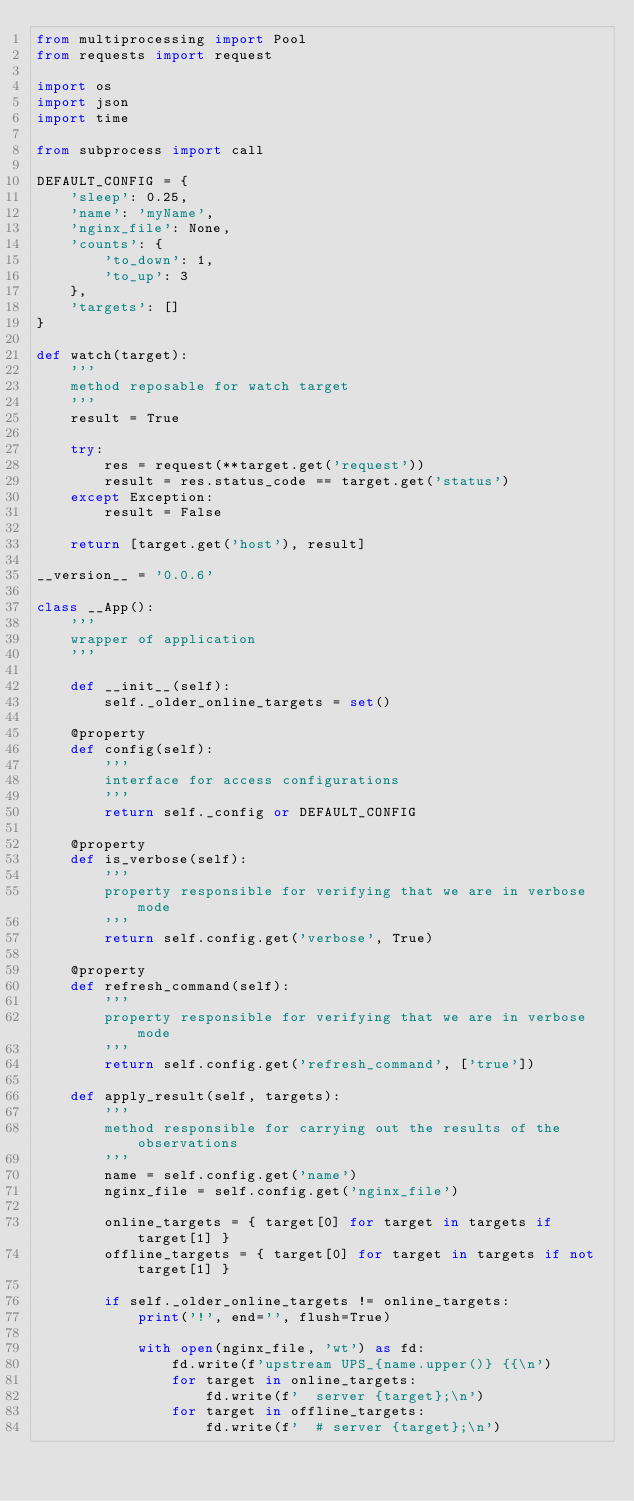Convert code to text. <code><loc_0><loc_0><loc_500><loc_500><_Python_>from multiprocessing import Pool
from requests import request

import os
import json
import time

from subprocess import call

DEFAULT_CONFIG = {
    'sleep': 0.25,
    'name': 'myName',
    'nginx_file': None,
    'counts': {
        'to_down': 1,
        'to_up': 3
    },
    'targets': []
}

def watch(target):
    '''
    method reposable for watch target
    '''
    result = True

    try:
        res = request(**target.get('request'))
        result = res.status_code == target.get('status')
    except Exception:
        result = False

    return [target.get('host'), result]

__version__ = '0.0.6'

class __App():
    '''
    wrapper of application
    '''

    def __init__(self):
        self._older_online_targets = set()

    @property
    def config(self):
        '''
        interface for access configurations
        '''
        return self._config or DEFAULT_CONFIG

    @property
    def is_verbose(self):
        '''
        property responsible for verifying that we are in verbose mode
        '''
        return self.config.get('verbose', True)

    @property
    def refresh_command(self):
        '''
        property responsible for verifying that we are in verbose mode
        '''
        return self.config.get('refresh_command', ['true'])

    def apply_result(self, targets):
        '''
        method responsible for carrying out the results of the observations
        '''
        name = self.config.get('name')
        nginx_file = self.config.get('nginx_file')
        
        online_targets = { target[0] for target in targets if target[1] }
        offline_targets = { target[0] for target in targets if not target[1] }

        if self._older_online_targets != online_targets:
            print('!', end='', flush=True)
        
            with open(nginx_file, 'wt') as fd:
                fd.write(f'upstream UPS_{name.upper()} {{\n')
                for target in online_targets:
                    fd.write(f'  server {target};\n')
                for target in offline_targets:
                    fd.write(f'  # server {target};\n')</code> 